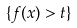Convert formula to latex. <formula><loc_0><loc_0><loc_500><loc_500>\{ f ( x ) > t \}</formula> 